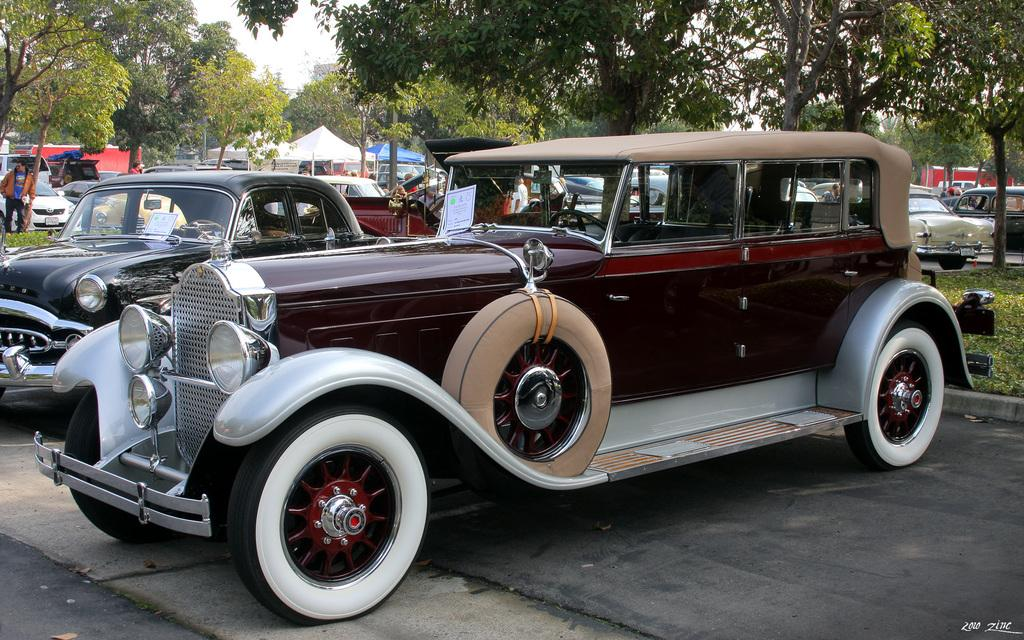What types of vehicles are on the ground in the image? The specific types of vehicles are not mentioned, but there are vehicles on the ground in the image. What can be seen in the background of the image? In the background of the image, there are trees, grass, people, the sky, a fence, and other objects. Can you describe the setting of the image? The image appears to be set outdoors, with vehicles on the ground and various elements visible in the background. What type of drum can be heard playing in the background of the image? There is no drum or sound present in the image; it is a still image with no audio component. 